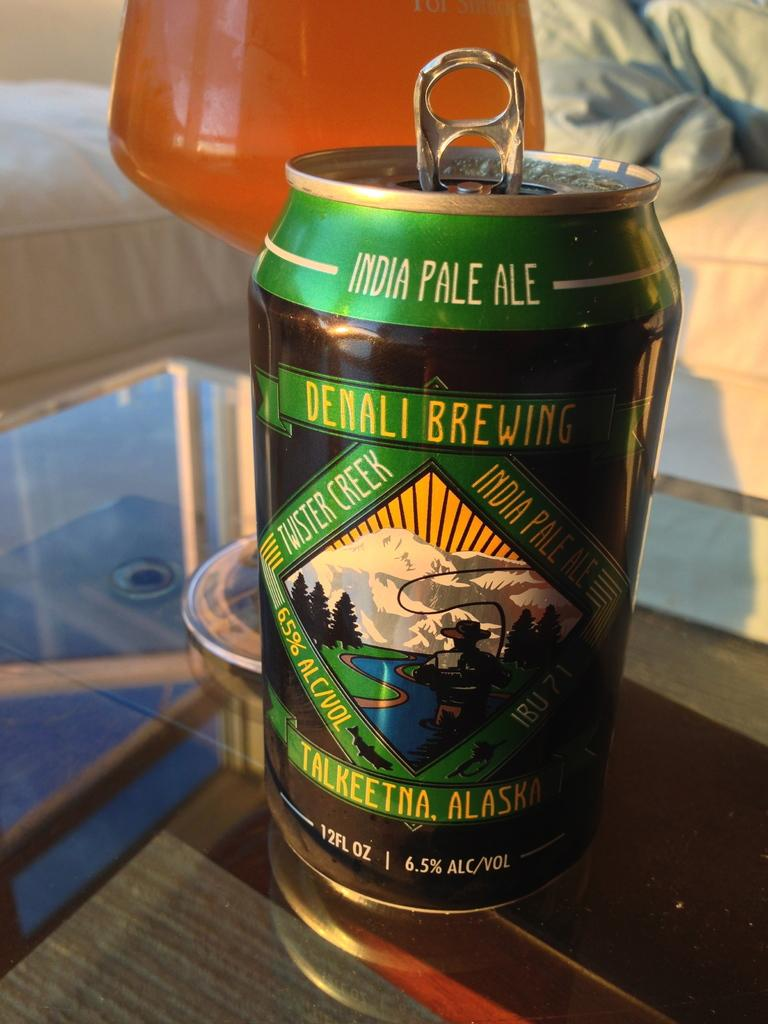<image>
Render a clear and concise summary of the photo. A can of beer from Denali Brewing has a snowy mountain on the label. 